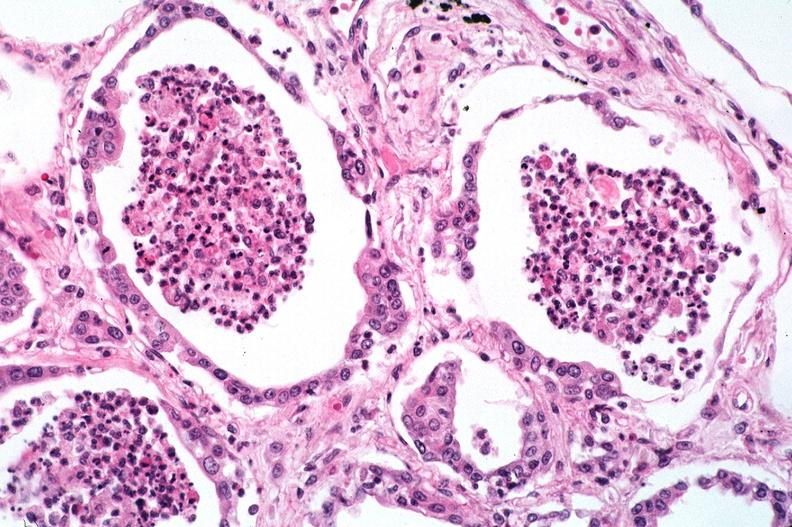does this image show lung, bronchopneumonia?
Answer the question using a single word or phrase. Yes 